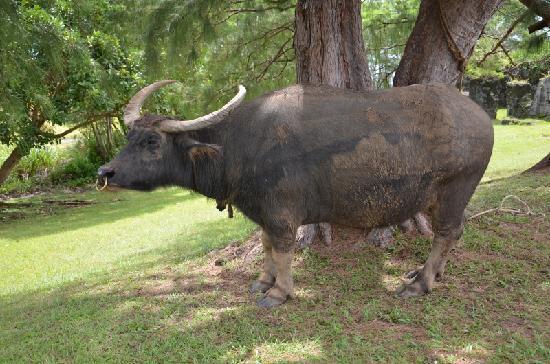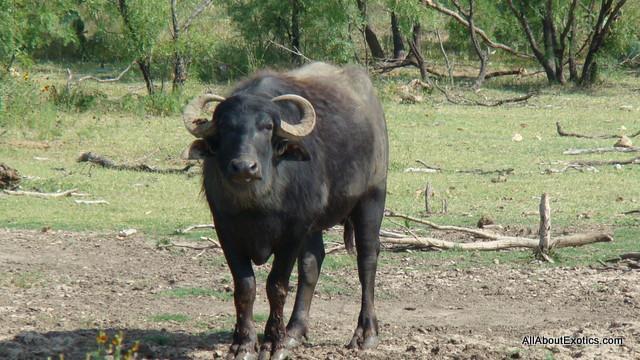The first image is the image on the left, the second image is the image on the right. For the images displayed, is the sentence "The oxen in the foreground of the two images have their bodies facing each other." factually correct? Answer yes or no. No. 